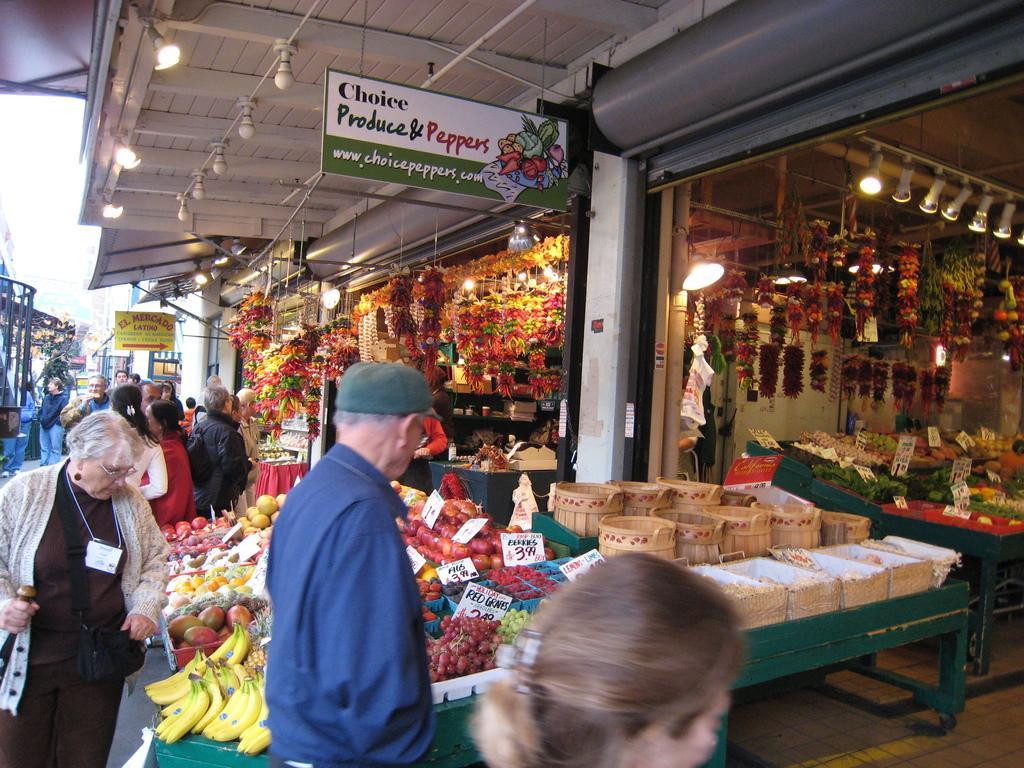How would you summarize this image in a sentence or two? In this image we can see electric bulbs attached to the roof, persons standing on the road, stores and fruits and vegetables arranged in rows along with the price tags. 